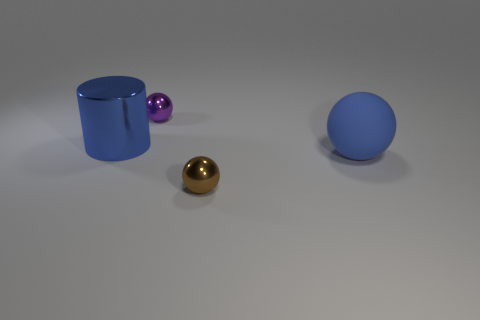If these objects were part of a larger arrangement, what sort of setting might they belong to? These objects might belong in an abstract art installation or a contemporary still life composition. The simplicity and the color choices suggest a modern aesthetic, possibly for decorative purposes in a minimalist or modernist setting. 